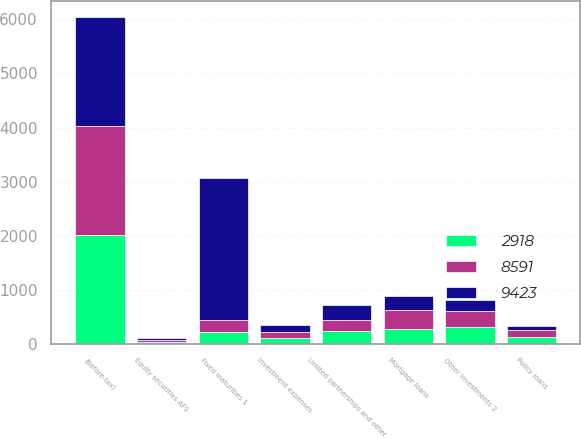Convert chart. <chart><loc_0><loc_0><loc_500><loc_500><stacked_bar_chart><ecel><fcel>(Before-tax)<fcel>Fixed maturities 1<fcel>Equity securities AFS<fcel>Mortgage loans<fcel>Policy loans<fcel>Limited partnerships and other<fcel>Other investments 2<fcel>Investment expenses<nl><fcel>9423<fcel>2013<fcel>2623<fcel>30<fcel>262<fcel>83<fcel>287<fcel>200<fcel>123<nl><fcel>8591<fcel>2012<fcel>221.5<fcel>37<fcel>337<fcel>119<fcel>196<fcel>297<fcel>111<nl><fcel>2918<fcel>2011<fcel>221.5<fcel>36<fcel>281<fcel>131<fcel>243<fcel>305<fcel>115<nl></chart> 